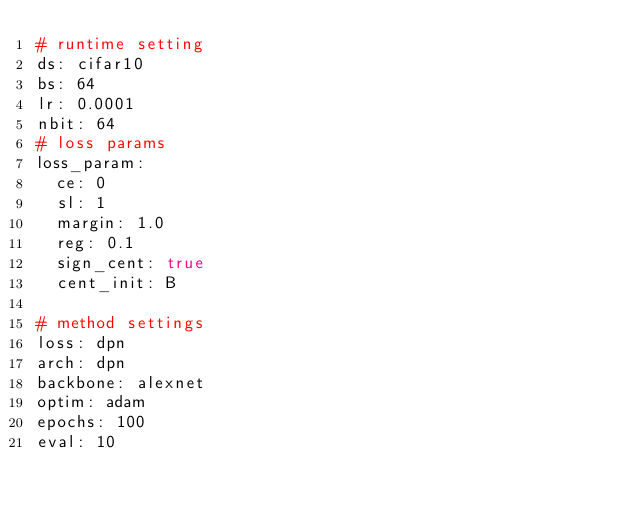Convert code to text. <code><loc_0><loc_0><loc_500><loc_500><_YAML_># runtime setting
ds: cifar10
bs: 64
lr: 0.0001
nbit: 64
# loss params
loss_param:
  ce: 0
  sl: 1
  margin: 1.0
  reg: 0.1
  sign_cent: true
  cent_init: B

# method settings
loss: dpn
arch: dpn
backbone: alexnet
optim: adam
epochs: 100
eval: 10</code> 